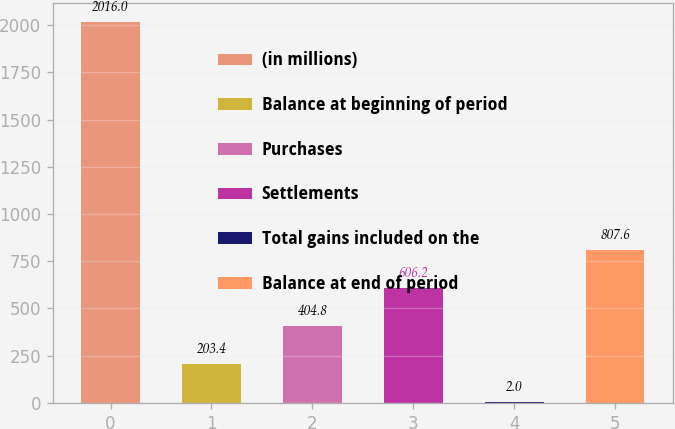Convert chart to OTSL. <chart><loc_0><loc_0><loc_500><loc_500><bar_chart><fcel>(in millions)<fcel>Balance at beginning of period<fcel>Purchases<fcel>Settlements<fcel>Total gains included on the<fcel>Balance at end of period<nl><fcel>2016<fcel>203.4<fcel>404.8<fcel>606.2<fcel>2<fcel>807.6<nl></chart> 